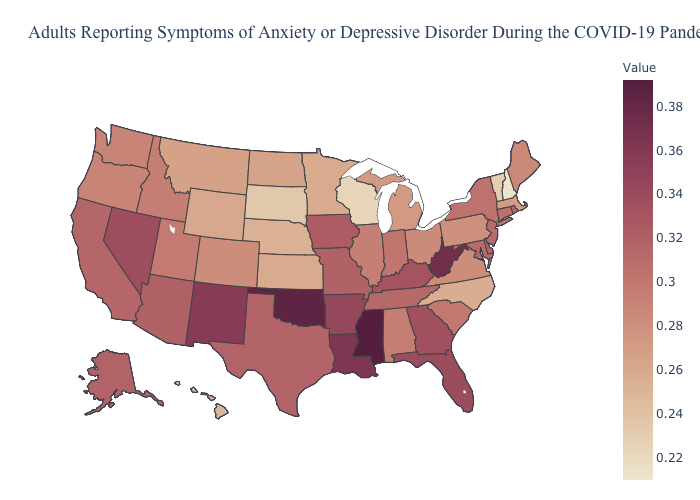Does Rhode Island have a higher value than Mississippi?
Answer briefly. No. Does New Hampshire have the lowest value in the Northeast?
Write a very short answer. Yes. Among the states that border Arizona , does California have the highest value?
Be succinct. No. Among the states that border Virginia , which have the highest value?
Keep it brief. West Virginia. Does North Dakota have the lowest value in the MidWest?
Write a very short answer. No. Which states have the lowest value in the USA?
Quick response, please. New Hampshire. 